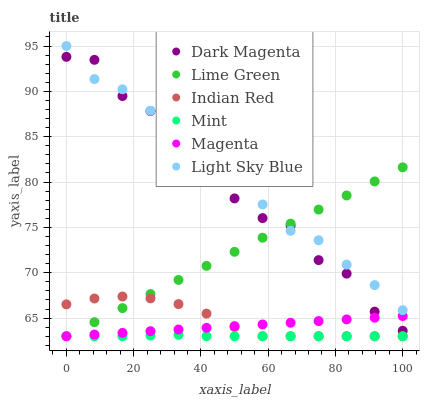Does Mint have the minimum area under the curve?
Answer yes or no. Yes. Does Light Sky Blue have the maximum area under the curve?
Answer yes or no. Yes. Does Lime Green have the minimum area under the curve?
Answer yes or no. No. Does Lime Green have the maximum area under the curve?
Answer yes or no. No. Is Lime Green the smoothest?
Answer yes or no. Yes. Is Dark Magenta the roughest?
Answer yes or no. Yes. Is Light Sky Blue the smoothest?
Answer yes or no. No. Is Light Sky Blue the roughest?
Answer yes or no. No. Does Lime Green have the lowest value?
Answer yes or no. Yes. Does Light Sky Blue have the lowest value?
Answer yes or no. No. Does Light Sky Blue have the highest value?
Answer yes or no. Yes. Does Lime Green have the highest value?
Answer yes or no. No. Is Indian Red less than Light Sky Blue?
Answer yes or no. Yes. Is Light Sky Blue greater than Indian Red?
Answer yes or no. Yes. Does Indian Red intersect Mint?
Answer yes or no. Yes. Is Indian Red less than Mint?
Answer yes or no. No. Is Indian Red greater than Mint?
Answer yes or no. No. Does Indian Red intersect Light Sky Blue?
Answer yes or no. No. 